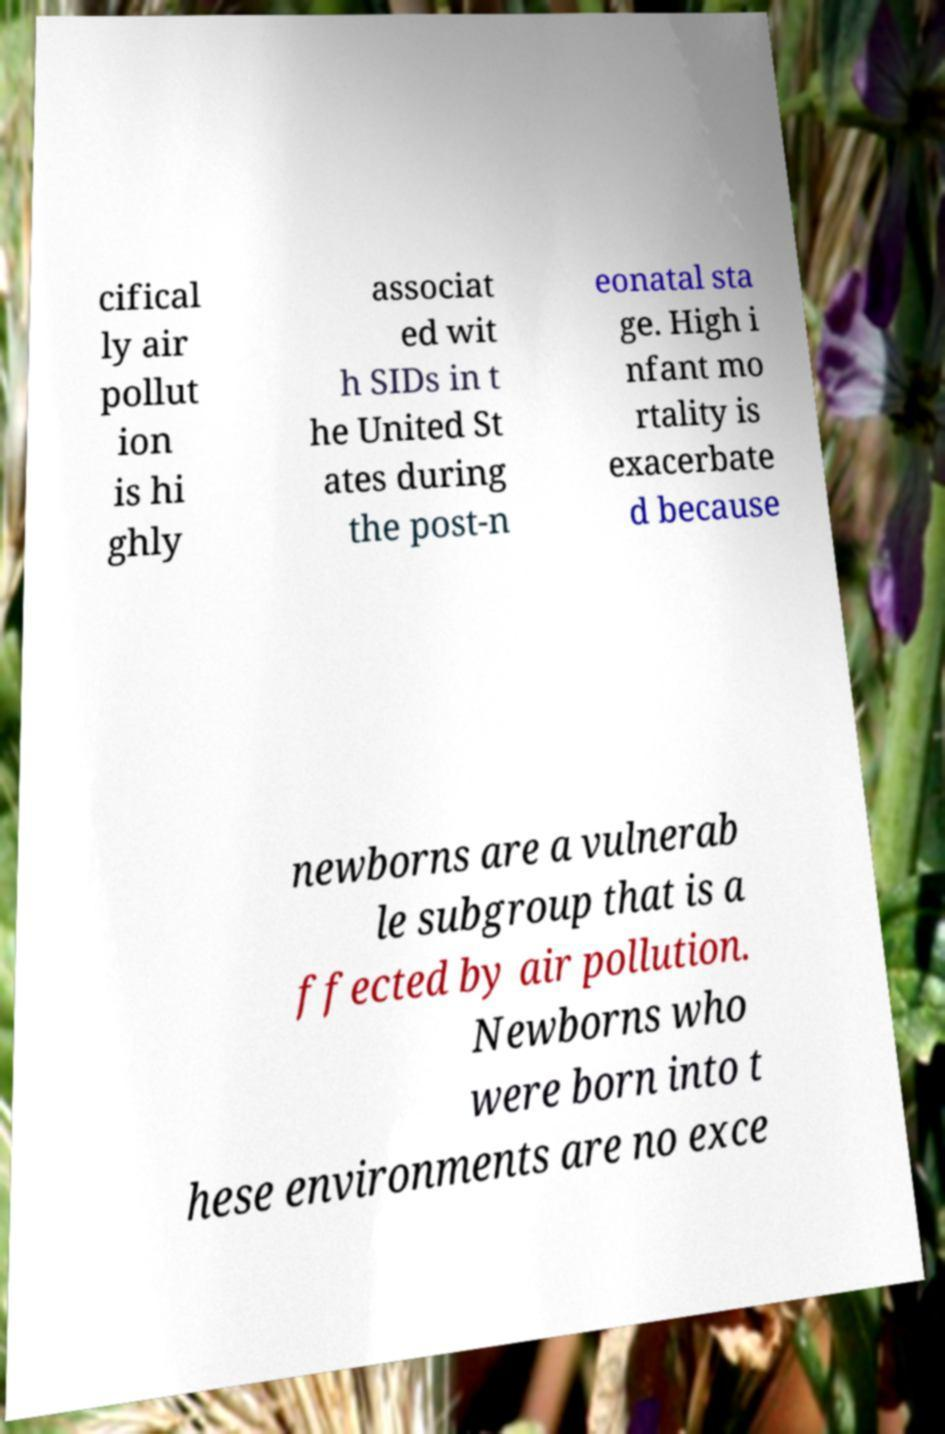Please read and relay the text visible in this image. What does it say? cifical ly air pollut ion is hi ghly associat ed wit h SIDs in t he United St ates during the post-n eonatal sta ge. High i nfant mo rtality is exacerbate d because newborns are a vulnerab le subgroup that is a ffected by air pollution. Newborns who were born into t hese environments are no exce 